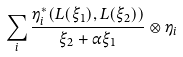<formula> <loc_0><loc_0><loc_500><loc_500>\sum _ { i } \frac { \eta _ { i } ^ { * } ( L ( \xi _ { 1 } ) , L ( \xi _ { 2 } ) ) } { \xi _ { 2 } + \alpha \xi _ { 1 } } \otimes \eta _ { i }</formula> 